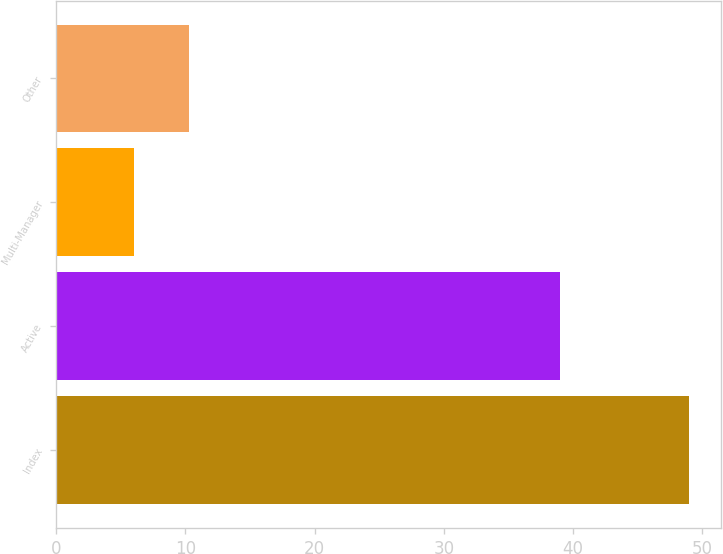Convert chart. <chart><loc_0><loc_0><loc_500><loc_500><bar_chart><fcel>Index<fcel>Active<fcel>Multi-Manager<fcel>Other<nl><fcel>49<fcel>39<fcel>6<fcel>10.3<nl></chart> 